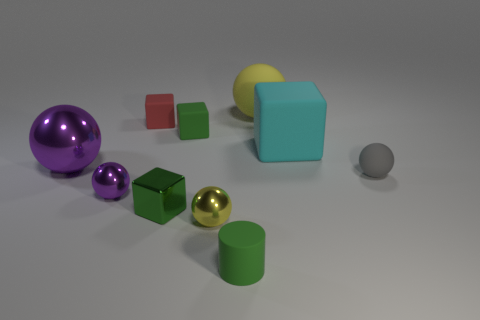Imagine if the scene is part of a child's educational game. Which shapes and colors could be used to teach counting and identification? This scene is perfect for an educational game. Children could learn to count using the six objects: two cubes (one red, one green), two spheres (one purple, one yellow), and two cylinders (one green, one teal). Identification can be taught by asking the child to match colors and shapes, such as finding all the green items or identifying which objects are cubes. 